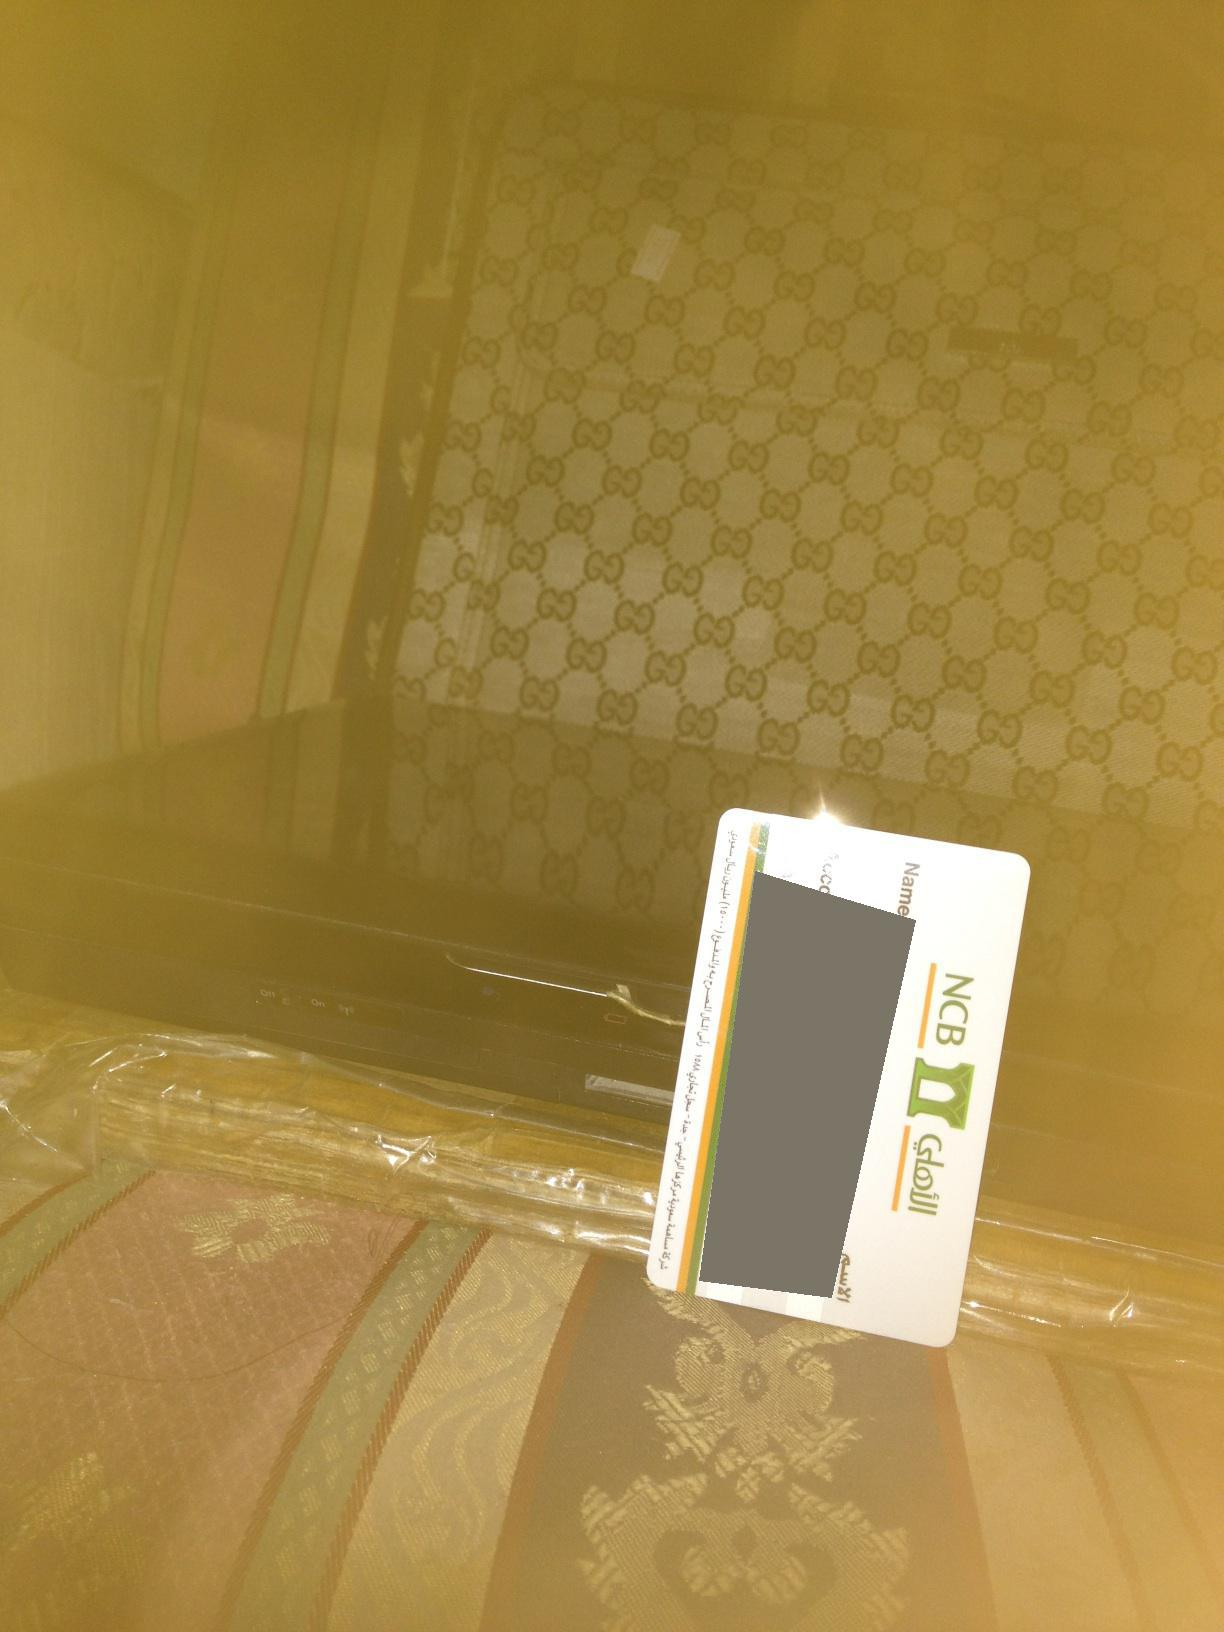Entertain an imaginative, whimsical idea involving the items in the picture. Picture this: the suitcase in the image is not just any suitcase, but a magical portal to a world where anything is possible. The credit card acts as a key that, when placed in special slots, unlocks different realms of fantastical adventures. Today, the card has unlocked a world where the electronics beneath the suitcase come to life. In a flash, the device transforms into a small, talking robotic guide named 'Spark,' who is ready to lead you through golden forests, over candy-coated mountains, and into starry galaxies. Every time you swipe the card in the suitcase, it cultivates a new, extraordinary adventure waiting just for you. 